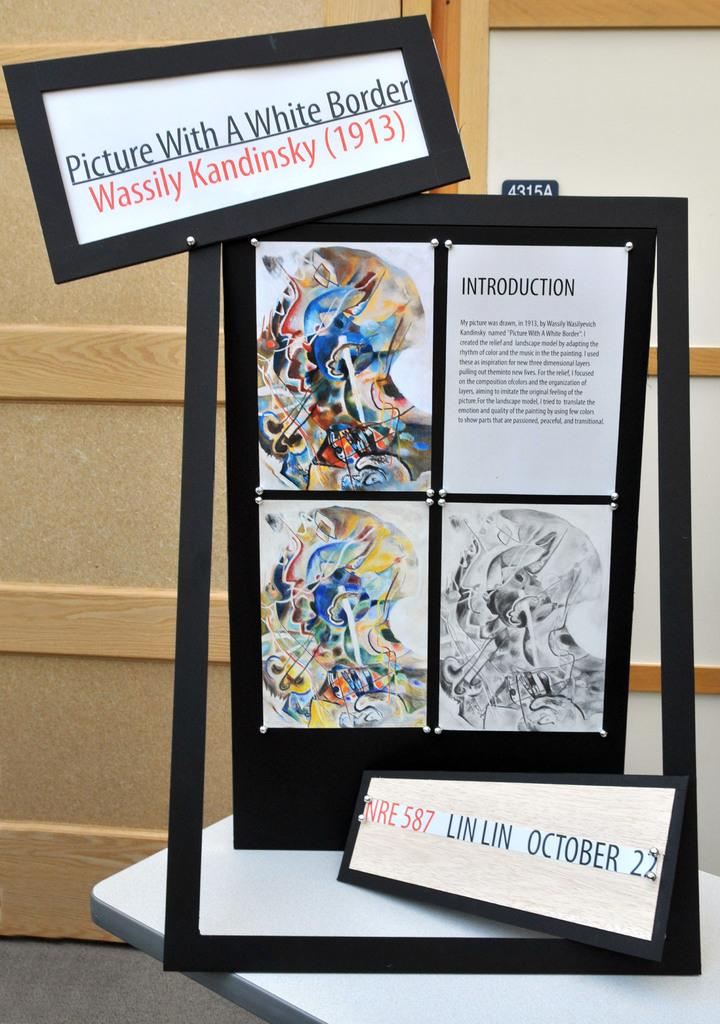<image>
Share a concise interpretation of the image provided. Sampling of artwork titled Picture with a white border by Wassily Kandinsky 